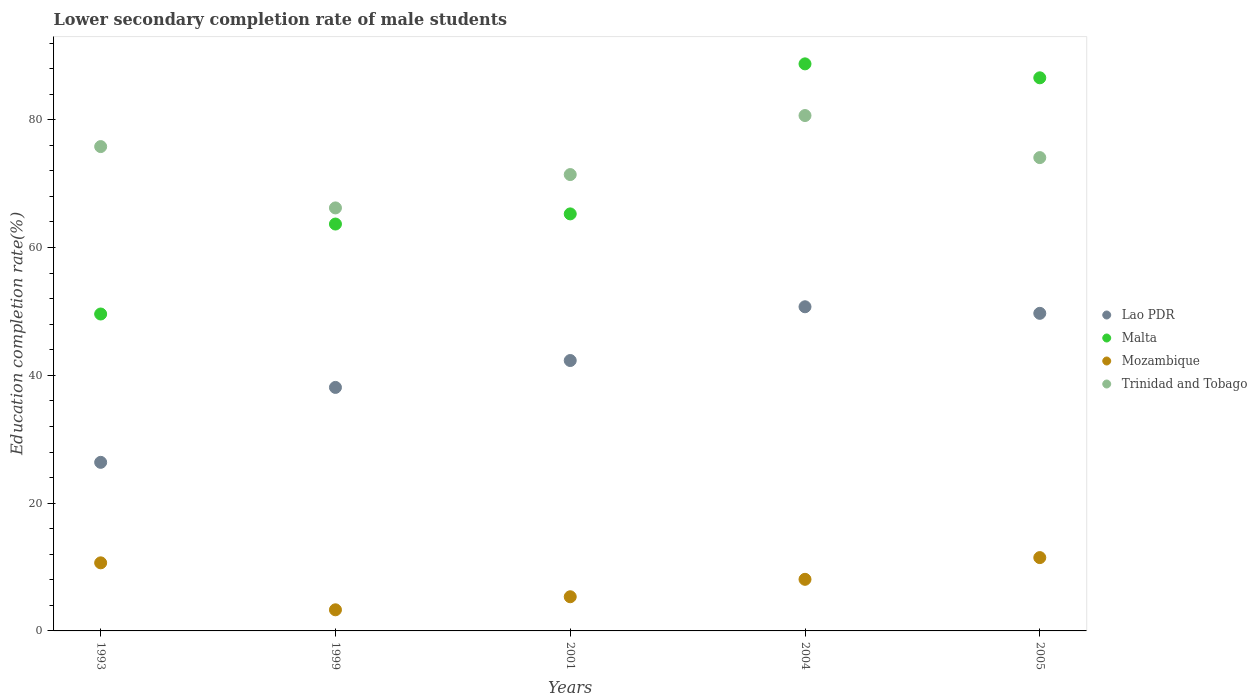How many different coloured dotlines are there?
Provide a succinct answer. 4. Is the number of dotlines equal to the number of legend labels?
Keep it short and to the point. Yes. What is the lower secondary completion rate of male students in Trinidad and Tobago in 2004?
Make the answer very short. 80.66. Across all years, what is the maximum lower secondary completion rate of male students in Malta?
Ensure brevity in your answer.  88.75. Across all years, what is the minimum lower secondary completion rate of male students in Malta?
Provide a short and direct response. 49.6. In which year was the lower secondary completion rate of male students in Lao PDR minimum?
Ensure brevity in your answer.  1993. What is the total lower secondary completion rate of male students in Lao PDR in the graph?
Your response must be concise. 207.25. What is the difference between the lower secondary completion rate of male students in Malta in 2001 and that in 2004?
Provide a short and direct response. -23.48. What is the difference between the lower secondary completion rate of male students in Mozambique in 2004 and the lower secondary completion rate of male students in Malta in 2005?
Make the answer very short. -78.49. What is the average lower secondary completion rate of male students in Mozambique per year?
Give a very brief answer. 7.77. In the year 2004, what is the difference between the lower secondary completion rate of male students in Trinidad and Tobago and lower secondary completion rate of male students in Lao PDR?
Ensure brevity in your answer.  29.93. What is the ratio of the lower secondary completion rate of male students in Mozambique in 1999 to that in 2001?
Keep it short and to the point. 0.62. Is the lower secondary completion rate of male students in Malta in 1993 less than that in 2004?
Your answer should be compact. Yes. What is the difference between the highest and the second highest lower secondary completion rate of male students in Malta?
Your response must be concise. 2.18. What is the difference between the highest and the lowest lower secondary completion rate of male students in Malta?
Give a very brief answer. 39.15. In how many years, is the lower secondary completion rate of male students in Mozambique greater than the average lower secondary completion rate of male students in Mozambique taken over all years?
Your answer should be compact. 3. Is the sum of the lower secondary completion rate of male students in Mozambique in 1993 and 2005 greater than the maximum lower secondary completion rate of male students in Lao PDR across all years?
Your answer should be compact. No. Is the lower secondary completion rate of male students in Trinidad and Tobago strictly greater than the lower secondary completion rate of male students in Malta over the years?
Keep it short and to the point. No. Is the lower secondary completion rate of male students in Lao PDR strictly less than the lower secondary completion rate of male students in Mozambique over the years?
Your response must be concise. No. How many dotlines are there?
Ensure brevity in your answer.  4. Are the values on the major ticks of Y-axis written in scientific E-notation?
Provide a succinct answer. No. Does the graph contain any zero values?
Your answer should be compact. No. Where does the legend appear in the graph?
Your answer should be very brief. Center right. How many legend labels are there?
Offer a terse response. 4. What is the title of the graph?
Provide a succinct answer. Lower secondary completion rate of male students. Does "Mali" appear as one of the legend labels in the graph?
Give a very brief answer. No. What is the label or title of the X-axis?
Make the answer very short. Years. What is the label or title of the Y-axis?
Your answer should be very brief. Education completion rate(%). What is the Education completion rate(%) in Lao PDR in 1993?
Your response must be concise. 26.38. What is the Education completion rate(%) in Malta in 1993?
Provide a short and direct response. 49.6. What is the Education completion rate(%) of Mozambique in 1993?
Provide a short and direct response. 10.65. What is the Education completion rate(%) of Trinidad and Tobago in 1993?
Provide a short and direct response. 75.8. What is the Education completion rate(%) in Lao PDR in 1999?
Ensure brevity in your answer.  38.11. What is the Education completion rate(%) of Malta in 1999?
Your answer should be compact. 63.68. What is the Education completion rate(%) in Mozambique in 1999?
Make the answer very short. 3.31. What is the Education completion rate(%) in Trinidad and Tobago in 1999?
Provide a succinct answer. 66.2. What is the Education completion rate(%) of Lao PDR in 2001?
Offer a very short reply. 42.32. What is the Education completion rate(%) of Malta in 2001?
Give a very brief answer. 65.27. What is the Education completion rate(%) of Mozambique in 2001?
Give a very brief answer. 5.35. What is the Education completion rate(%) in Trinidad and Tobago in 2001?
Keep it short and to the point. 71.42. What is the Education completion rate(%) of Lao PDR in 2004?
Give a very brief answer. 50.73. What is the Education completion rate(%) in Malta in 2004?
Ensure brevity in your answer.  88.75. What is the Education completion rate(%) of Mozambique in 2004?
Make the answer very short. 8.08. What is the Education completion rate(%) in Trinidad and Tobago in 2004?
Offer a very short reply. 80.66. What is the Education completion rate(%) of Lao PDR in 2005?
Offer a very short reply. 49.7. What is the Education completion rate(%) of Malta in 2005?
Ensure brevity in your answer.  86.56. What is the Education completion rate(%) of Mozambique in 2005?
Ensure brevity in your answer.  11.48. What is the Education completion rate(%) in Trinidad and Tobago in 2005?
Give a very brief answer. 74.08. Across all years, what is the maximum Education completion rate(%) in Lao PDR?
Offer a very short reply. 50.73. Across all years, what is the maximum Education completion rate(%) of Malta?
Make the answer very short. 88.75. Across all years, what is the maximum Education completion rate(%) in Mozambique?
Your response must be concise. 11.48. Across all years, what is the maximum Education completion rate(%) in Trinidad and Tobago?
Offer a very short reply. 80.66. Across all years, what is the minimum Education completion rate(%) of Lao PDR?
Your answer should be very brief. 26.38. Across all years, what is the minimum Education completion rate(%) of Malta?
Your answer should be compact. 49.6. Across all years, what is the minimum Education completion rate(%) of Mozambique?
Give a very brief answer. 3.31. Across all years, what is the minimum Education completion rate(%) of Trinidad and Tobago?
Your answer should be compact. 66.2. What is the total Education completion rate(%) in Lao PDR in the graph?
Provide a succinct answer. 207.25. What is the total Education completion rate(%) of Malta in the graph?
Your answer should be very brief. 353.85. What is the total Education completion rate(%) of Mozambique in the graph?
Make the answer very short. 38.86. What is the total Education completion rate(%) of Trinidad and Tobago in the graph?
Offer a terse response. 368.16. What is the difference between the Education completion rate(%) of Lao PDR in 1993 and that in 1999?
Keep it short and to the point. -11.73. What is the difference between the Education completion rate(%) in Malta in 1993 and that in 1999?
Your response must be concise. -14.08. What is the difference between the Education completion rate(%) in Mozambique in 1993 and that in 1999?
Make the answer very short. 7.35. What is the difference between the Education completion rate(%) of Trinidad and Tobago in 1993 and that in 1999?
Your answer should be very brief. 9.6. What is the difference between the Education completion rate(%) in Lao PDR in 1993 and that in 2001?
Give a very brief answer. -15.93. What is the difference between the Education completion rate(%) in Malta in 1993 and that in 2001?
Offer a terse response. -15.67. What is the difference between the Education completion rate(%) of Mozambique in 1993 and that in 2001?
Make the answer very short. 5.31. What is the difference between the Education completion rate(%) in Trinidad and Tobago in 1993 and that in 2001?
Provide a succinct answer. 4.38. What is the difference between the Education completion rate(%) of Lao PDR in 1993 and that in 2004?
Make the answer very short. -24.35. What is the difference between the Education completion rate(%) in Malta in 1993 and that in 2004?
Your answer should be compact. -39.15. What is the difference between the Education completion rate(%) in Mozambique in 1993 and that in 2004?
Offer a very short reply. 2.58. What is the difference between the Education completion rate(%) in Trinidad and Tobago in 1993 and that in 2004?
Provide a succinct answer. -4.86. What is the difference between the Education completion rate(%) of Lao PDR in 1993 and that in 2005?
Your answer should be very brief. -23.32. What is the difference between the Education completion rate(%) in Malta in 1993 and that in 2005?
Your answer should be compact. -36.97. What is the difference between the Education completion rate(%) in Mozambique in 1993 and that in 2005?
Keep it short and to the point. -0.82. What is the difference between the Education completion rate(%) in Trinidad and Tobago in 1993 and that in 2005?
Provide a succinct answer. 1.72. What is the difference between the Education completion rate(%) of Lao PDR in 1999 and that in 2001?
Your answer should be compact. -4.21. What is the difference between the Education completion rate(%) in Malta in 1999 and that in 2001?
Give a very brief answer. -1.59. What is the difference between the Education completion rate(%) of Mozambique in 1999 and that in 2001?
Make the answer very short. -2.04. What is the difference between the Education completion rate(%) in Trinidad and Tobago in 1999 and that in 2001?
Your answer should be compact. -5.22. What is the difference between the Education completion rate(%) of Lao PDR in 1999 and that in 2004?
Make the answer very short. -12.62. What is the difference between the Education completion rate(%) in Malta in 1999 and that in 2004?
Your answer should be compact. -25.07. What is the difference between the Education completion rate(%) of Mozambique in 1999 and that in 2004?
Your answer should be very brief. -4.77. What is the difference between the Education completion rate(%) of Trinidad and Tobago in 1999 and that in 2004?
Your answer should be compact. -14.46. What is the difference between the Education completion rate(%) in Lao PDR in 1999 and that in 2005?
Give a very brief answer. -11.6. What is the difference between the Education completion rate(%) of Malta in 1999 and that in 2005?
Your answer should be compact. -22.89. What is the difference between the Education completion rate(%) of Mozambique in 1999 and that in 2005?
Provide a succinct answer. -8.17. What is the difference between the Education completion rate(%) of Trinidad and Tobago in 1999 and that in 2005?
Offer a terse response. -7.87. What is the difference between the Education completion rate(%) of Lao PDR in 2001 and that in 2004?
Your answer should be compact. -8.41. What is the difference between the Education completion rate(%) in Malta in 2001 and that in 2004?
Provide a short and direct response. -23.48. What is the difference between the Education completion rate(%) in Mozambique in 2001 and that in 2004?
Make the answer very short. -2.73. What is the difference between the Education completion rate(%) in Trinidad and Tobago in 2001 and that in 2004?
Keep it short and to the point. -9.24. What is the difference between the Education completion rate(%) in Lao PDR in 2001 and that in 2005?
Your response must be concise. -7.39. What is the difference between the Education completion rate(%) of Malta in 2001 and that in 2005?
Keep it short and to the point. -21.3. What is the difference between the Education completion rate(%) of Mozambique in 2001 and that in 2005?
Your answer should be compact. -6.13. What is the difference between the Education completion rate(%) in Trinidad and Tobago in 2001 and that in 2005?
Offer a terse response. -2.66. What is the difference between the Education completion rate(%) in Lao PDR in 2004 and that in 2005?
Give a very brief answer. 1.03. What is the difference between the Education completion rate(%) of Malta in 2004 and that in 2005?
Provide a succinct answer. 2.18. What is the difference between the Education completion rate(%) of Mozambique in 2004 and that in 2005?
Provide a short and direct response. -3.4. What is the difference between the Education completion rate(%) in Trinidad and Tobago in 2004 and that in 2005?
Your answer should be compact. 6.58. What is the difference between the Education completion rate(%) of Lao PDR in 1993 and the Education completion rate(%) of Malta in 1999?
Provide a succinct answer. -37.29. What is the difference between the Education completion rate(%) in Lao PDR in 1993 and the Education completion rate(%) in Mozambique in 1999?
Offer a terse response. 23.08. What is the difference between the Education completion rate(%) in Lao PDR in 1993 and the Education completion rate(%) in Trinidad and Tobago in 1999?
Ensure brevity in your answer.  -39.82. What is the difference between the Education completion rate(%) in Malta in 1993 and the Education completion rate(%) in Mozambique in 1999?
Provide a short and direct response. 46.29. What is the difference between the Education completion rate(%) of Malta in 1993 and the Education completion rate(%) of Trinidad and Tobago in 1999?
Offer a terse response. -16.6. What is the difference between the Education completion rate(%) in Mozambique in 1993 and the Education completion rate(%) in Trinidad and Tobago in 1999?
Ensure brevity in your answer.  -55.55. What is the difference between the Education completion rate(%) in Lao PDR in 1993 and the Education completion rate(%) in Malta in 2001?
Provide a succinct answer. -38.88. What is the difference between the Education completion rate(%) in Lao PDR in 1993 and the Education completion rate(%) in Mozambique in 2001?
Offer a very short reply. 21.04. What is the difference between the Education completion rate(%) of Lao PDR in 1993 and the Education completion rate(%) of Trinidad and Tobago in 2001?
Make the answer very short. -45.04. What is the difference between the Education completion rate(%) in Malta in 1993 and the Education completion rate(%) in Mozambique in 2001?
Keep it short and to the point. 44.25. What is the difference between the Education completion rate(%) of Malta in 1993 and the Education completion rate(%) of Trinidad and Tobago in 2001?
Your response must be concise. -21.82. What is the difference between the Education completion rate(%) in Mozambique in 1993 and the Education completion rate(%) in Trinidad and Tobago in 2001?
Make the answer very short. -60.77. What is the difference between the Education completion rate(%) in Lao PDR in 1993 and the Education completion rate(%) in Malta in 2004?
Ensure brevity in your answer.  -62.36. What is the difference between the Education completion rate(%) of Lao PDR in 1993 and the Education completion rate(%) of Mozambique in 2004?
Provide a short and direct response. 18.31. What is the difference between the Education completion rate(%) in Lao PDR in 1993 and the Education completion rate(%) in Trinidad and Tobago in 2004?
Your answer should be very brief. -54.28. What is the difference between the Education completion rate(%) of Malta in 1993 and the Education completion rate(%) of Mozambique in 2004?
Give a very brief answer. 41.52. What is the difference between the Education completion rate(%) in Malta in 1993 and the Education completion rate(%) in Trinidad and Tobago in 2004?
Your answer should be compact. -31.06. What is the difference between the Education completion rate(%) of Mozambique in 1993 and the Education completion rate(%) of Trinidad and Tobago in 2004?
Your answer should be very brief. -70. What is the difference between the Education completion rate(%) of Lao PDR in 1993 and the Education completion rate(%) of Malta in 2005?
Your response must be concise. -60.18. What is the difference between the Education completion rate(%) in Lao PDR in 1993 and the Education completion rate(%) in Mozambique in 2005?
Your response must be concise. 14.91. What is the difference between the Education completion rate(%) of Lao PDR in 1993 and the Education completion rate(%) of Trinidad and Tobago in 2005?
Provide a short and direct response. -47.69. What is the difference between the Education completion rate(%) of Malta in 1993 and the Education completion rate(%) of Mozambique in 2005?
Your answer should be compact. 38.12. What is the difference between the Education completion rate(%) of Malta in 1993 and the Education completion rate(%) of Trinidad and Tobago in 2005?
Offer a very short reply. -24.48. What is the difference between the Education completion rate(%) of Mozambique in 1993 and the Education completion rate(%) of Trinidad and Tobago in 2005?
Your answer should be very brief. -63.42. What is the difference between the Education completion rate(%) in Lao PDR in 1999 and the Education completion rate(%) in Malta in 2001?
Make the answer very short. -27.16. What is the difference between the Education completion rate(%) of Lao PDR in 1999 and the Education completion rate(%) of Mozambique in 2001?
Your answer should be very brief. 32.76. What is the difference between the Education completion rate(%) of Lao PDR in 1999 and the Education completion rate(%) of Trinidad and Tobago in 2001?
Offer a very short reply. -33.31. What is the difference between the Education completion rate(%) in Malta in 1999 and the Education completion rate(%) in Mozambique in 2001?
Keep it short and to the point. 58.33. What is the difference between the Education completion rate(%) of Malta in 1999 and the Education completion rate(%) of Trinidad and Tobago in 2001?
Ensure brevity in your answer.  -7.74. What is the difference between the Education completion rate(%) of Mozambique in 1999 and the Education completion rate(%) of Trinidad and Tobago in 2001?
Your answer should be very brief. -68.12. What is the difference between the Education completion rate(%) of Lao PDR in 1999 and the Education completion rate(%) of Malta in 2004?
Ensure brevity in your answer.  -50.64. What is the difference between the Education completion rate(%) of Lao PDR in 1999 and the Education completion rate(%) of Mozambique in 2004?
Give a very brief answer. 30.03. What is the difference between the Education completion rate(%) of Lao PDR in 1999 and the Education completion rate(%) of Trinidad and Tobago in 2004?
Keep it short and to the point. -42.55. What is the difference between the Education completion rate(%) in Malta in 1999 and the Education completion rate(%) in Mozambique in 2004?
Offer a very short reply. 55.6. What is the difference between the Education completion rate(%) of Malta in 1999 and the Education completion rate(%) of Trinidad and Tobago in 2004?
Offer a very short reply. -16.98. What is the difference between the Education completion rate(%) of Mozambique in 1999 and the Education completion rate(%) of Trinidad and Tobago in 2004?
Your answer should be compact. -77.35. What is the difference between the Education completion rate(%) of Lao PDR in 1999 and the Education completion rate(%) of Malta in 2005?
Keep it short and to the point. -48.46. What is the difference between the Education completion rate(%) of Lao PDR in 1999 and the Education completion rate(%) of Mozambique in 2005?
Your response must be concise. 26.63. What is the difference between the Education completion rate(%) in Lao PDR in 1999 and the Education completion rate(%) in Trinidad and Tobago in 2005?
Your response must be concise. -35.97. What is the difference between the Education completion rate(%) in Malta in 1999 and the Education completion rate(%) in Mozambique in 2005?
Your answer should be very brief. 52.2. What is the difference between the Education completion rate(%) in Malta in 1999 and the Education completion rate(%) in Trinidad and Tobago in 2005?
Give a very brief answer. -10.4. What is the difference between the Education completion rate(%) in Mozambique in 1999 and the Education completion rate(%) in Trinidad and Tobago in 2005?
Your answer should be very brief. -70.77. What is the difference between the Education completion rate(%) of Lao PDR in 2001 and the Education completion rate(%) of Malta in 2004?
Provide a succinct answer. -46.43. What is the difference between the Education completion rate(%) in Lao PDR in 2001 and the Education completion rate(%) in Mozambique in 2004?
Make the answer very short. 34.24. What is the difference between the Education completion rate(%) in Lao PDR in 2001 and the Education completion rate(%) in Trinidad and Tobago in 2004?
Give a very brief answer. -38.34. What is the difference between the Education completion rate(%) of Malta in 2001 and the Education completion rate(%) of Mozambique in 2004?
Provide a succinct answer. 57.19. What is the difference between the Education completion rate(%) in Malta in 2001 and the Education completion rate(%) in Trinidad and Tobago in 2004?
Offer a very short reply. -15.39. What is the difference between the Education completion rate(%) of Mozambique in 2001 and the Education completion rate(%) of Trinidad and Tobago in 2004?
Keep it short and to the point. -75.31. What is the difference between the Education completion rate(%) in Lao PDR in 2001 and the Education completion rate(%) in Malta in 2005?
Provide a short and direct response. -44.25. What is the difference between the Education completion rate(%) in Lao PDR in 2001 and the Education completion rate(%) in Mozambique in 2005?
Your answer should be very brief. 30.84. What is the difference between the Education completion rate(%) in Lao PDR in 2001 and the Education completion rate(%) in Trinidad and Tobago in 2005?
Provide a succinct answer. -31.76. What is the difference between the Education completion rate(%) of Malta in 2001 and the Education completion rate(%) of Mozambique in 2005?
Your response must be concise. 53.79. What is the difference between the Education completion rate(%) in Malta in 2001 and the Education completion rate(%) in Trinidad and Tobago in 2005?
Provide a short and direct response. -8.81. What is the difference between the Education completion rate(%) in Mozambique in 2001 and the Education completion rate(%) in Trinidad and Tobago in 2005?
Give a very brief answer. -68.73. What is the difference between the Education completion rate(%) in Lao PDR in 2004 and the Education completion rate(%) in Malta in 2005?
Offer a terse response. -35.83. What is the difference between the Education completion rate(%) in Lao PDR in 2004 and the Education completion rate(%) in Mozambique in 2005?
Provide a succinct answer. 39.26. What is the difference between the Education completion rate(%) of Lao PDR in 2004 and the Education completion rate(%) of Trinidad and Tobago in 2005?
Make the answer very short. -23.35. What is the difference between the Education completion rate(%) in Malta in 2004 and the Education completion rate(%) in Mozambique in 2005?
Give a very brief answer. 77.27. What is the difference between the Education completion rate(%) of Malta in 2004 and the Education completion rate(%) of Trinidad and Tobago in 2005?
Your answer should be compact. 14.67. What is the difference between the Education completion rate(%) of Mozambique in 2004 and the Education completion rate(%) of Trinidad and Tobago in 2005?
Keep it short and to the point. -66. What is the average Education completion rate(%) of Lao PDR per year?
Your response must be concise. 41.45. What is the average Education completion rate(%) in Malta per year?
Provide a succinct answer. 70.77. What is the average Education completion rate(%) in Mozambique per year?
Your answer should be compact. 7.77. What is the average Education completion rate(%) of Trinidad and Tobago per year?
Make the answer very short. 73.63. In the year 1993, what is the difference between the Education completion rate(%) in Lao PDR and Education completion rate(%) in Malta?
Give a very brief answer. -23.21. In the year 1993, what is the difference between the Education completion rate(%) in Lao PDR and Education completion rate(%) in Mozambique?
Your answer should be very brief. 15.73. In the year 1993, what is the difference between the Education completion rate(%) in Lao PDR and Education completion rate(%) in Trinidad and Tobago?
Provide a short and direct response. -49.42. In the year 1993, what is the difference between the Education completion rate(%) in Malta and Education completion rate(%) in Mozambique?
Give a very brief answer. 38.94. In the year 1993, what is the difference between the Education completion rate(%) in Malta and Education completion rate(%) in Trinidad and Tobago?
Provide a short and direct response. -26.2. In the year 1993, what is the difference between the Education completion rate(%) of Mozambique and Education completion rate(%) of Trinidad and Tobago?
Provide a short and direct response. -65.15. In the year 1999, what is the difference between the Education completion rate(%) in Lao PDR and Education completion rate(%) in Malta?
Your answer should be compact. -25.57. In the year 1999, what is the difference between the Education completion rate(%) in Lao PDR and Education completion rate(%) in Mozambique?
Your answer should be compact. 34.8. In the year 1999, what is the difference between the Education completion rate(%) in Lao PDR and Education completion rate(%) in Trinidad and Tobago?
Your response must be concise. -28.09. In the year 1999, what is the difference between the Education completion rate(%) of Malta and Education completion rate(%) of Mozambique?
Provide a short and direct response. 60.37. In the year 1999, what is the difference between the Education completion rate(%) in Malta and Education completion rate(%) in Trinidad and Tobago?
Keep it short and to the point. -2.52. In the year 1999, what is the difference between the Education completion rate(%) in Mozambique and Education completion rate(%) in Trinidad and Tobago?
Your answer should be compact. -62.9. In the year 2001, what is the difference between the Education completion rate(%) of Lao PDR and Education completion rate(%) of Malta?
Ensure brevity in your answer.  -22.95. In the year 2001, what is the difference between the Education completion rate(%) in Lao PDR and Education completion rate(%) in Mozambique?
Your response must be concise. 36.97. In the year 2001, what is the difference between the Education completion rate(%) in Lao PDR and Education completion rate(%) in Trinidad and Tobago?
Your answer should be compact. -29.1. In the year 2001, what is the difference between the Education completion rate(%) in Malta and Education completion rate(%) in Mozambique?
Ensure brevity in your answer.  59.92. In the year 2001, what is the difference between the Education completion rate(%) in Malta and Education completion rate(%) in Trinidad and Tobago?
Keep it short and to the point. -6.15. In the year 2001, what is the difference between the Education completion rate(%) of Mozambique and Education completion rate(%) of Trinidad and Tobago?
Keep it short and to the point. -66.07. In the year 2004, what is the difference between the Education completion rate(%) of Lao PDR and Education completion rate(%) of Malta?
Give a very brief answer. -38.01. In the year 2004, what is the difference between the Education completion rate(%) of Lao PDR and Education completion rate(%) of Mozambique?
Your answer should be compact. 42.66. In the year 2004, what is the difference between the Education completion rate(%) of Lao PDR and Education completion rate(%) of Trinidad and Tobago?
Ensure brevity in your answer.  -29.93. In the year 2004, what is the difference between the Education completion rate(%) of Malta and Education completion rate(%) of Mozambique?
Provide a short and direct response. 80.67. In the year 2004, what is the difference between the Education completion rate(%) in Malta and Education completion rate(%) in Trinidad and Tobago?
Ensure brevity in your answer.  8.09. In the year 2004, what is the difference between the Education completion rate(%) of Mozambique and Education completion rate(%) of Trinidad and Tobago?
Provide a short and direct response. -72.58. In the year 2005, what is the difference between the Education completion rate(%) in Lao PDR and Education completion rate(%) in Malta?
Your response must be concise. -36.86. In the year 2005, what is the difference between the Education completion rate(%) in Lao PDR and Education completion rate(%) in Mozambique?
Provide a succinct answer. 38.23. In the year 2005, what is the difference between the Education completion rate(%) in Lao PDR and Education completion rate(%) in Trinidad and Tobago?
Make the answer very short. -24.37. In the year 2005, what is the difference between the Education completion rate(%) in Malta and Education completion rate(%) in Mozambique?
Offer a very short reply. 75.09. In the year 2005, what is the difference between the Education completion rate(%) in Malta and Education completion rate(%) in Trinidad and Tobago?
Offer a terse response. 12.49. In the year 2005, what is the difference between the Education completion rate(%) of Mozambique and Education completion rate(%) of Trinidad and Tobago?
Your response must be concise. -62.6. What is the ratio of the Education completion rate(%) of Lao PDR in 1993 to that in 1999?
Your answer should be compact. 0.69. What is the ratio of the Education completion rate(%) of Malta in 1993 to that in 1999?
Your answer should be very brief. 0.78. What is the ratio of the Education completion rate(%) in Mozambique in 1993 to that in 1999?
Your answer should be very brief. 3.22. What is the ratio of the Education completion rate(%) in Trinidad and Tobago in 1993 to that in 1999?
Make the answer very short. 1.15. What is the ratio of the Education completion rate(%) in Lao PDR in 1993 to that in 2001?
Ensure brevity in your answer.  0.62. What is the ratio of the Education completion rate(%) in Malta in 1993 to that in 2001?
Ensure brevity in your answer.  0.76. What is the ratio of the Education completion rate(%) of Mozambique in 1993 to that in 2001?
Provide a short and direct response. 1.99. What is the ratio of the Education completion rate(%) of Trinidad and Tobago in 1993 to that in 2001?
Offer a terse response. 1.06. What is the ratio of the Education completion rate(%) in Lao PDR in 1993 to that in 2004?
Give a very brief answer. 0.52. What is the ratio of the Education completion rate(%) of Malta in 1993 to that in 2004?
Your answer should be compact. 0.56. What is the ratio of the Education completion rate(%) in Mozambique in 1993 to that in 2004?
Keep it short and to the point. 1.32. What is the ratio of the Education completion rate(%) of Trinidad and Tobago in 1993 to that in 2004?
Your answer should be compact. 0.94. What is the ratio of the Education completion rate(%) in Lao PDR in 1993 to that in 2005?
Your answer should be compact. 0.53. What is the ratio of the Education completion rate(%) in Malta in 1993 to that in 2005?
Ensure brevity in your answer.  0.57. What is the ratio of the Education completion rate(%) in Mozambique in 1993 to that in 2005?
Offer a terse response. 0.93. What is the ratio of the Education completion rate(%) of Trinidad and Tobago in 1993 to that in 2005?
Make the answer very short. 1.02. What is the ratio of the Education completion rate(%) in Lao PDR in 1999 to that in 2001?
Offer a terse response. 0.9. What is the ratio of the Education completion rate(%) in Malta in 1999 to that in 2001?
Provide a short and direct response. 0.98. What is the ratio of the Education completion rate(%) of Mozambique in 1999 to that in 2001?
Provide a short and direct response. 0.62. What is the ratio of the Education completion rate(%) in Trinidad and Tobago in 1999 to that in 2001?
Offer a very short reply. 0.93. What is the ratio of the Education completion rate(%) in Lao PDR in 1999 to that in 2004?
Keep it short and to the point. 0.75. What is the ratio of the Education completion rate(%) of Malta in 1999 to that in 2004?
Offer a very short reply. 0.72. What is the ratio of the Education completion rate(%) in Mozambique in 1999 to that in 2004?
Provide a short and direct response. 0.41. What is the ratio of the Education completion rate(%) of Trinidad and Tobago in 1999 to that in 2004?
Your answer should be compact. 0.82. What is the ratio of the Education completion rate(%) in Lao PDR in 1999 to that in 2005?
Give a very brief answer. 0.77. What is the ratio of the Education completion rate(%) in Malta in 1999 to that in 2005?
Offer a very short reply. 0.74. What is the ratio of the Education completion rate(%) in Mozambique in 1999 to that in 2005?
Make the answer very short. 0.29. What is the ratio of the Education completion rate(%) in Trinidad and Tobago in 1999 to that in 2005?
Give a very brief answer. 0.89. What is the ratio of the Education completion rate(%) in Lao PDR in 2001 to that in 2004?
Keep it short and to the point. 0.83. What is the ratio of the Education completion rate(%) of Malta in 2001 to that in 2004?
Your answer should be very brief. 0.74. What is the ratio of the Education completion rate(%) in Mozambique in 2001 to that in 2004?
Keep it short and to the point. 0.66. What is the ratio of the Education completion rate(%) of Trinidad and Tobago in 2001 to that in 2004?
Provide a short and direct response. 0.89. What is the ratio of the Education completion rate(%) in Lao PDR in 2001 to that in 2005?
Offer a very short reply. 0.85. What is the ratio of the Education completion rate(%) of Malta in 2001 to that in 2005?
Your answer should be compact. 0.75. What is the ratio of the Education completion rate(%) of Mozambique in 2001 to that in 2005?
Your response must be concise. 0.47. What is the ratio of the Education completion rate(%) in Trinidad and Tobago in 2001 to that in 2005?
Offer a very short reply. 0.96. What is the ratio of the Education completion rate(%) of Lao PDR in 2004 to that in 2005?
Provide a short and direct response. 1.02. What is the ratio of the Education completion rate(%) of Malta in 2004 to that in 2005?
Offer a terse response. 1.03. What is the ratio of the Education completion rate(%) in Mozambique in 2004 to that in 2005?
Provide a short and direct response. 0.7. What is the ratio of the Education completion rate(%) of Trinidad and Tobago in 2004 to that in 2005?
Provide a short and direct response. 1.09. What is the difference between the highest and the second highest Education completion rate(%) in Lao PDR?
Your answer should be very brief. 1.03. What is the difference between the highest and the second highest Education completion rate(%) of Malta?
Offer a terse response. 2.18. What is the difference between the highest and the second highest Education completion rate(%) in Mozambique?
Keep it short and to the point. 0.82. What is the difference between the highest and the second highest Education completion rate(%) of Trinidad and Tobago?
Give a very brief answer. 4.86. What is the difference between the highest and the lowest Education completion rate(%) in Lao PDR?
Make the answer very short. 24.35. What is the difference between the highest and the lowest Education completion rate(%) in Malta?
Your answer should be compact. 39.15. What is the difference between the highest and the lowest Education completion rate(%) in Mozambique?
Give a very brief answer. 8.17. What is the difference between the highest and the lowest Education completion rate(%) in Trinidad and Tobago?
Your response must be concise. 14.46. 